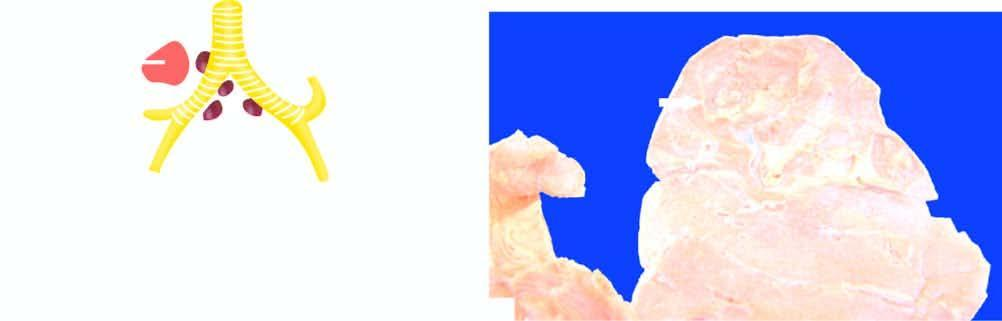s the affected area shows consolidation of lung parenchyma surrounding the cavity?
Answer the question using a single word or phrase. No 